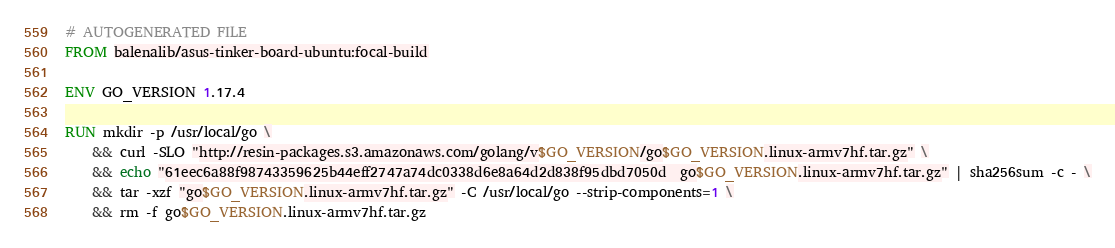<code> <loc_0><loc_0><loc_500><loc_500><_Dockerfile_># AUTOGENERATED FILE
FROM balenalib/asus-tinker-board-ubuntu:focal-build

ENV GO_VERSION 1.17.4

RUN mkdir -p /usr/local/go \
	&& curl -SLO "http://resin-packages.s3.amazonaws.com/golang/v$GO_VERSION/go$GO_VERSION.linux-armv7hf.tar.gz" \
	&& echo "61eec6a88f98743359625b44eff2747a74dc0338d6e8a64d2d838f95dbd7050d  go$GO_VERSION.linux-armv7hf.tar.gz" | sha256sum -c - \
	&& tar -xzf "go$GO_VERSION.linux-armv7hf.tar.gz" -C /usr/local/go --strip-components=1 \
	&& rm -f go$GO_VERSION.linux-armv7hf.tar.gz
</code> 